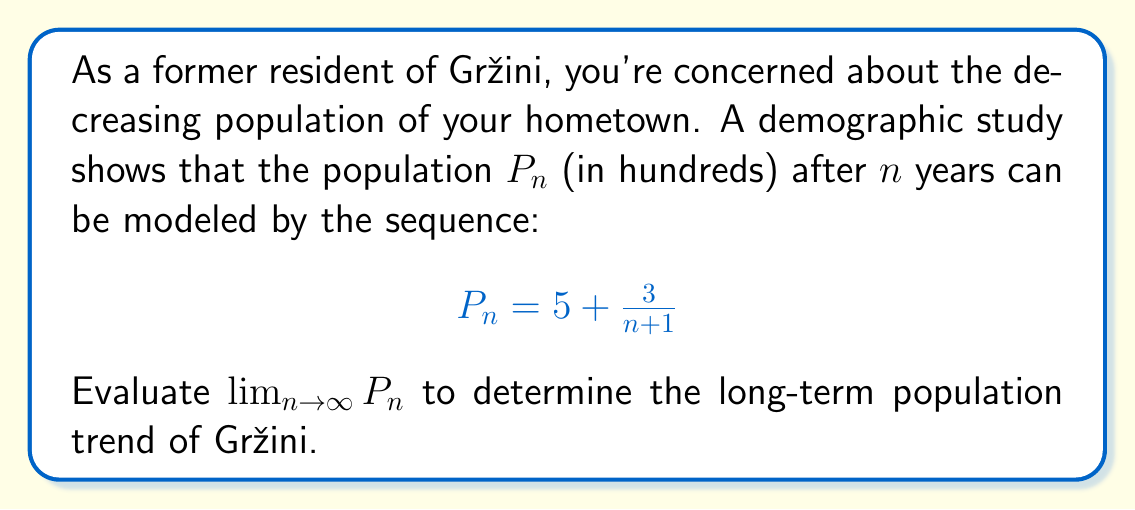Can you answer this question? To evaluate the limit of this sequence as $n$ approaches infinity, we'll follow these steps:

1) First, let's examine the general term of the sequence:

   $$P_n = 5 + \frac{3}{n+1}$$

2) As $n$ approaches infinity, we need to consider what happens to each part of this expression:

   - The constant term 5 remains unchanged.
   - We need to evaluate $\lim_{n \to \infty} \frac{3}{n+1}$

3) For the fraction $\frac{3}{n+1}$, as $n$ approaches infinity, the denominator grows infinitely large while the numerator remains constant. Therefore:

   $$\lim_{n \to \infty} \frac{3}{n+1} = 0$$

4) Now, we can combine these results:

   $$\lim_{n \to \infty} P_n = \lim_{n \to \infty} (5 + \frac{3}{n+1}) = 5 + \lim_{n \to \infty} \frac{3}{n+1} = 5 + 0 = 5$$

5) Therefore, the limit of the sequence as $n$ approaches infinity is 5.

This means that in the long term, the population of Gržini is expected to stabilize around 500 people (remember that $P_n$ was in hundreds).
Answer: $\lim_{n \to \infty} P_n = 5$ 